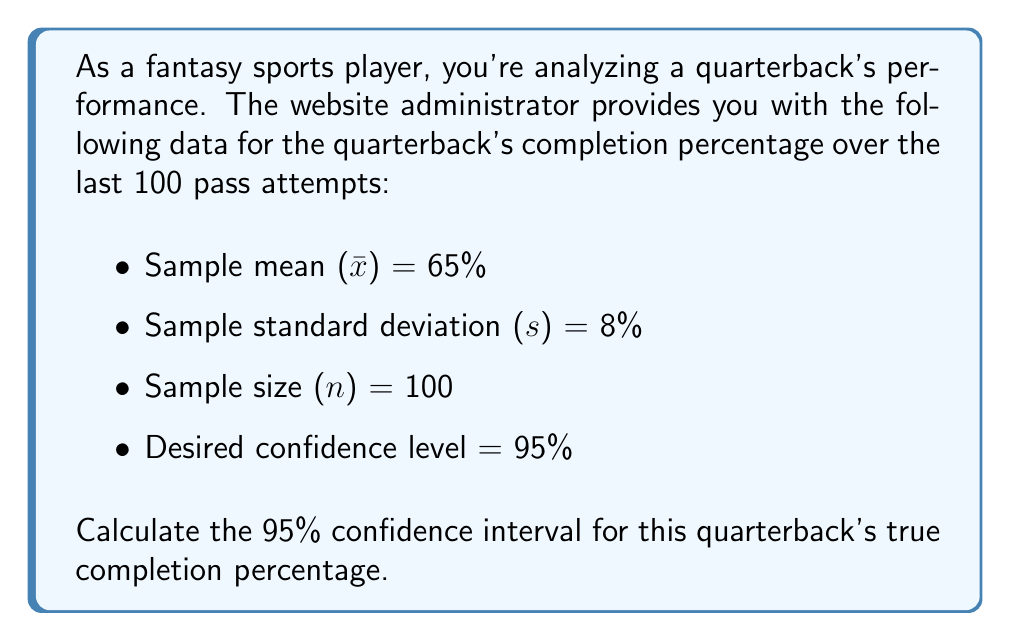Can you solve this math problem? To calculate the confidence interval, we'll follow these steps:

1) The formula for a confidence interval is:

   $$\text{CI} = \bar{x} \pm t_{\alpha/2} \cdot \frac{s}{\sqrt{n}}$$

   Where $t_{\alpha/2}$ is the t-value for the desired confidence level with n-1 degrees of freedom.

2) We have:
   $\bar{x} = 65\%$
   $s = 8\%$
   $n = 100$
   Confidence level = 95%, so $\alpha = 1 - 0.95 = 0.05$

3) Degrees of freedom = n - 1 = 100 - 1 = 99

4) Looking up the t-value for 95% confidence and 99 degrees of freedom:
   $t_{0.025, 99} \approx 1.984$

5) Now we can calculate the margin of error:

   $$\text{Margin of Error} = t_{\alpha/2} \cdot \frac{s}{\sqrt{n}} = 1.984 \cdot \frac{8\%}{\sqrt{100}} = 1.984 \cdot 0.8\% = 1.5872\%$$

6) The confidence interval is therefore:

   $$65\% \pm 1.5872\%$$

7) Calculate the lower and upper bounds:
   Lower bound: $65\% - 1.5872\% = 63.4128\%$
   Upper bound: $65\% + 1.5872\% = 66.5872\%$
Answer: (63.41%, 66.59%) 